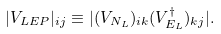<formula> <loc_0><loc_0><loc_500><loc_500>| V _ { L E P } | _ { i j } \equiv | ( V _ { N _ { L } } ) _ { i k } ( V _ { E _ { L } } ^ { \dag } ) _ { k j } | .</formula> 